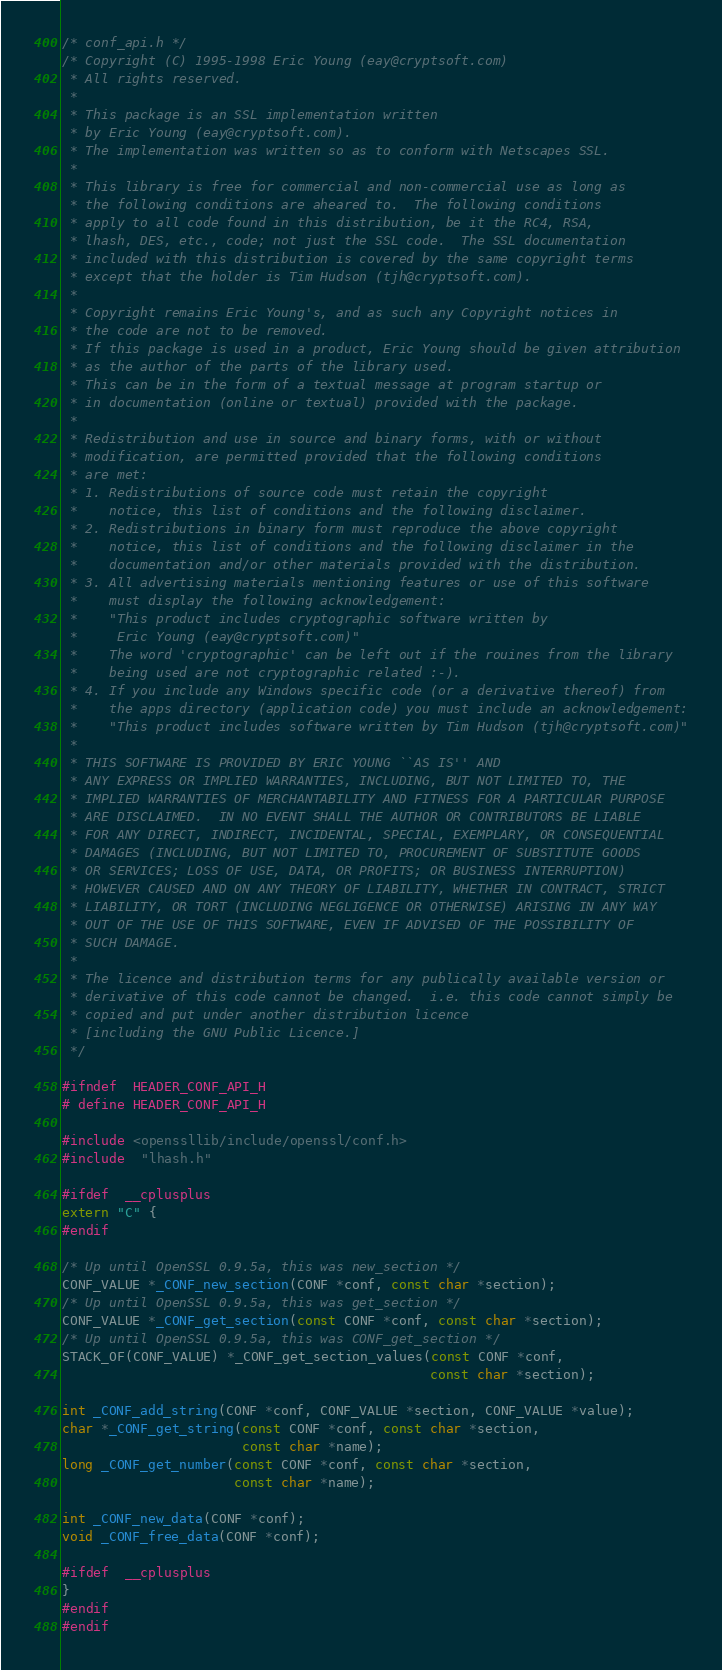<code> <loc_0><loc_0><loc_500><loc_500><_C_>/* conf_api.h */
/* Copyright (C) 1995-1998 Eric Young (eay@cryptsoft.com)
 * All rights reserved.
 *
 * This package is an SSL implementation written
 * by Eric Young (eay@cryptsoft.com).
 * The implementation was written so as to conform with Netscapes SSL.
 *
 * This library is free for commercial and non-commercial use as long as
 * the following conditions are aheared to.  The following conditions
 * apply to all code found in this distribution, be it the RC4, RSA,
 * lhash, DES, etc., code; not just the SSL code.  The SSL documentation
 * included with this distribution is covered by the same copyright terms
 * except that the holder is Tim Hudson (tjh@cryptsoft.com).
 *
 * Copyright remains Eric Young's, and as such any Copyright notices in
 * the code are not to be removed.
 * If this package is used in a product, Eric Young should be given attribution
 * as the author of the parts of the library used.
 * This can be in the form of a textual message at program startup or
 * in documentation (online or textual) provided with the package.
 *
 * Redistribution and use in source and binary forms, with or without
 * modification, are permitted provided that the following conditions
 * are met:
 * 1. Redistributions of source code must retain the copyright
 *    notice, this list of conditions and the following disclaimer.
 * 2. Redistributions in binary form must reproduce the above copyright
 *    notice, this list of conditions and the following disclaimer in the
 *    documentation and/or other materials provided with the distribution.
 * 3. All advertising materials mentioning features or use of this software
 *    must display the following acknowledgement:
 *    "This product includes cryptographic software written by
 *     Eric Young (eay@cryptsoft.com)"
 *    The word 'cryptographic' can be left out if the rouines from the library
 *    being used are not cryptographic related :-).
 * 4. If you include any Windows specific code (or a derivative thereof) from
 *    the apps directory (application code) you must include an acknowledgement:
 *    "This product includes software written by Tim Hudson (tjh@cryptsoft.com)"
 *
 * THIS SOFTWARE IS PROVIDED BY ERIC YOUNG ``AS IS'' AND
 * ANY EXPRESS OR IMPLIED WARRANTIES, INCLUDING, BUT NOT LIMITED TO, THE
 * IMPLIED WARRANTIES OF MERCHANTABILITY AND FITNESS FOR A PARTICULAR PURPOSE
 * ARE DISCLAIMED.  IN NO EVENT SHALL THE AUTHOR OR CONTRIBUTORS BE LIABLE
 * FOR ANY DIRECT, INDIRECT, INCIDENTAL, SPECIAL, EXEMPLARY, OR CONSEQUENTIAL
 * DAMAGES (INCLUDING, BUT NOT LIMITED TO, PROCUREMENT OF SUBSTITUTE GOODS
 * OR SERVICES; LOSS OF USE, DATA, OR PROFITS; OR BUSINESS INTERRUPTION)
 * HOWEVER CAUSED AND ON ANY THEORY OF LIABILITY, WHETHER IN CONTRACT, STRICT
 * LIABILITY, OR TORT (INCLUDING NEGLIGENCE OR OTHERWISE) ARISING IN ANY WAY
 * OUT OF THE USE OF THIS SOFTWARE, EVEN IF ADVISED OF THE POSSIBILITY OF
 * SUCH DAMAGE.
 *
 * The licence and distribution terms for any publically available version or
 * derivative of this code cannot be changed.  i.e. this code cannot simply be
 * copied and put under another distribution licence
 * [including the GNU Public Licence.]
 */

#ifndef  HEADER_CONF_API_H
# define HEADER_CONF_API_H

#include <openssllib/include/openssl/conf.h>
#include  "lhash.h"

#ifdef  __cplusplus
extern "C" {
#endif

/* Up until OpenSSL 0.9.5a, this was new_section */
CONF_VALUE *_CONF_new_section(CONF *conf, const char *section);
/* Up until OpenSSL 0.9.5a, this was get_section */
CONF_VALUE *_CONF_get_section(const CONF *conf, const char *section);
/* Up until OpenSSL 0.9.5a, this was CONF_get_section */
STACK_OF(CONF_VALUE) *_CONF_get_section_values(const CONF *conf,
                                               const char *section);

int _CONF_add_string(CONF *conf, CONF_VALUE *section, CONF_VALUE *value);
char *_CONF_get_string(const CONF *conf, const char *section,
                       const char *name);
long _CONF_get_number(const CONF *conf, const char *section,
                      const char *name);

int _CONF_new_data(CONF *conf);
void _CONF_free_data(CONF *conf);

#ifdef  __cplusplus
}
#endif
#endif
</code> 